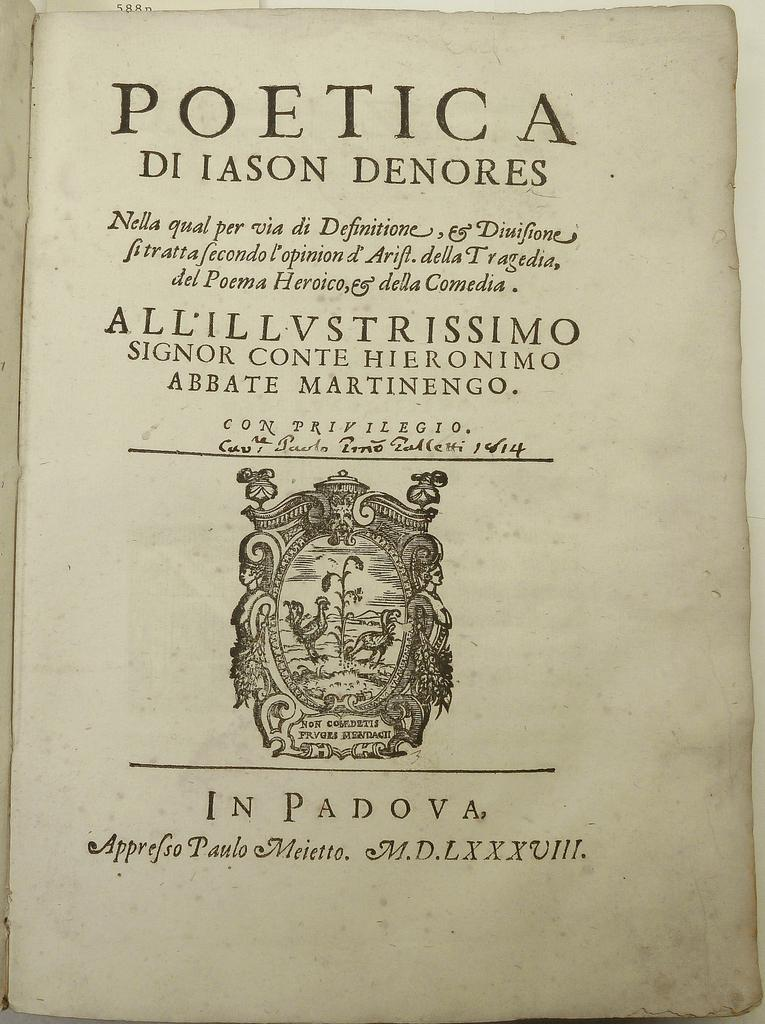Provide a one-sentence caption for the provided image. A book called the Poetica Di Jason Denores. 